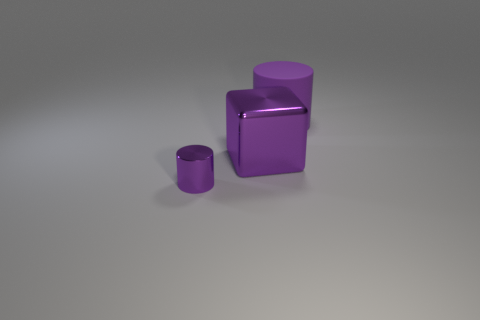Add 3 big purple objects. How many objects exist? 6 Subtract all blocks. How many objects are left? 2 Subtract 0 green spheres. How many objects are left? 3 Subtract all big purple matte cylinders. Subtract all tiny purple metallic objects. How many objects are left? 1 Add 3 big purple rubber cylinders. How many big purple rubber cylinders are left? 4 Add 1 small purple metal cylinders. How many small purple metal cylinders exist? 2 